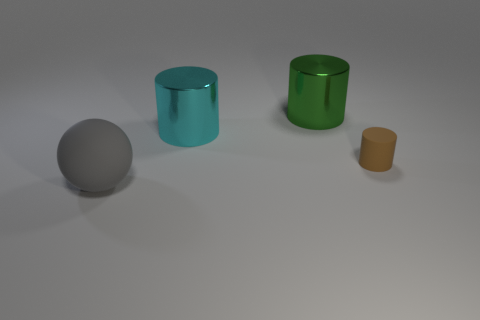Add 3 small purple matte balls. How many objects exist? 7 Subtract all cylinders. How many objects are left? 1 Add 4 large cyan metallic things. How many large cyan metallic things are left? 5 Add 2 cyan things. How many cyan things exist? 3 Subtract 0 blue blocks. How many objects are left? 4 Subtract all cyan metal objects. Subtract all large cylinders. How many objects are left? 1 